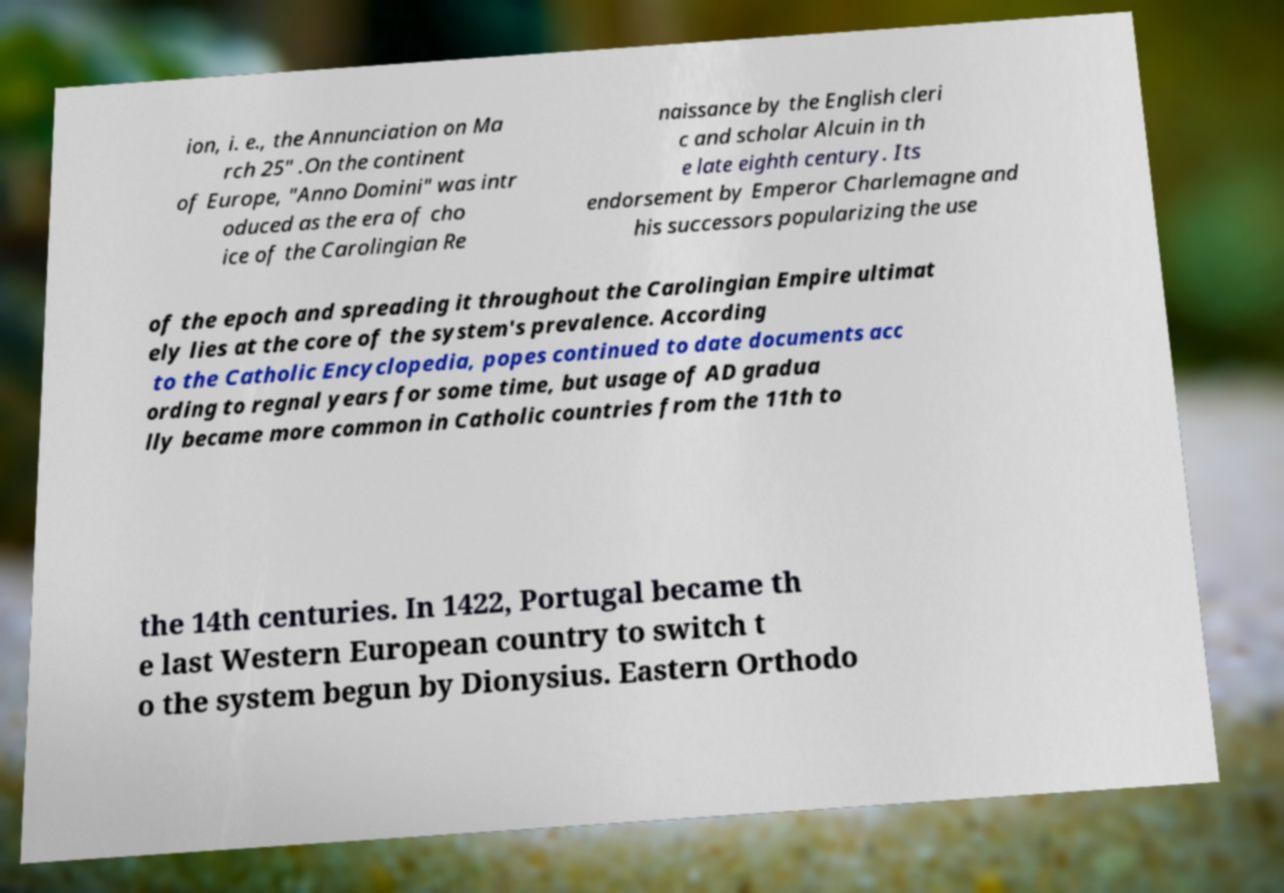Can you accurately transcribe the text from the provided image for me? ion, i. e., the Annunciation on Ma rch 25" .On the continent of Europe, "Anno Domini" was intr oduced as the era of cho ice of the Carolingian Re naissance by the English cleri c and scholar Alcuin in th e late eighth century. Its endorsement by Emperor Charlemagne and his successors popularizing the use of the epoch and spreading it throughout the Carolingian Empire ultimat ely lies at the core of the system's prevalence. According to the Catholic Encyclopedia, popes continued to date documents acc ording to regnal years for some time, but usage of AD gradua lly became more common in Catholic countries from the 11th to the 14th centuries. In 1422, Portugal became th e last Western European country to switch t o the system begun by Dionysius. Eastern Orthodo 